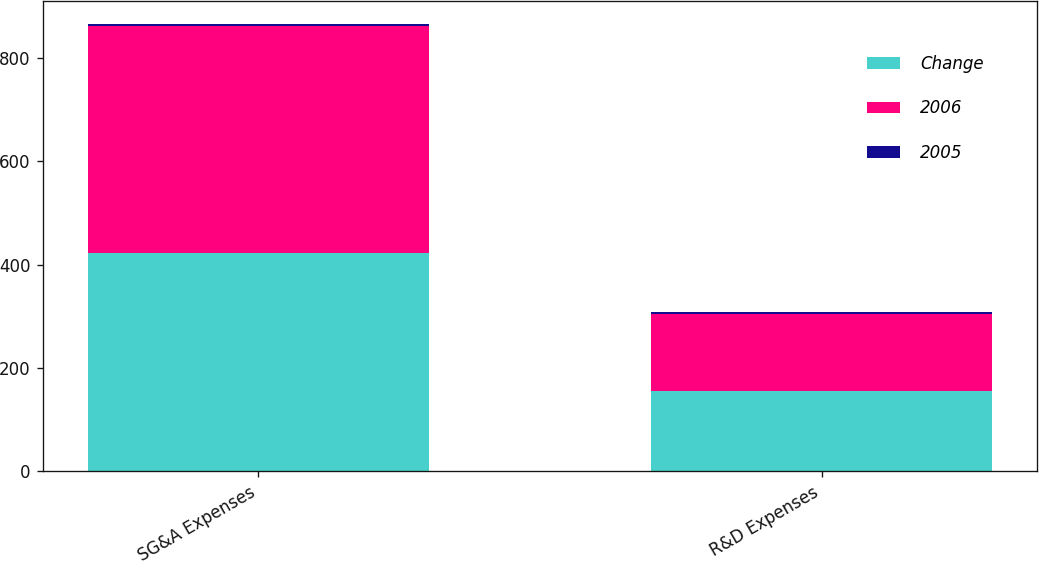<chart> <loc_0><loc_0><loc_500><loc_500><stacked_bar_chart><ecel><fcel>SG&A Expenses<fcel>R&D Expenses<nl><fcel>Change<fcel>423<fcel>155<nl><fcel>2006<fcel>439<fcel>150<nl><fcel>2005<fcel>4<fcel>3<nl></chart> 